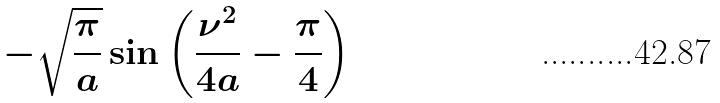Convert formula to latex. <formula><loc_0><loc_0><loc_500><loc_500>- { \sqrt { \frac { \pi } { a } } } \sin \left ( { \frac { \nu ^ { 2 } } { 4 a } } - { \frac { \pi } { 4 } } \right )</formula> 